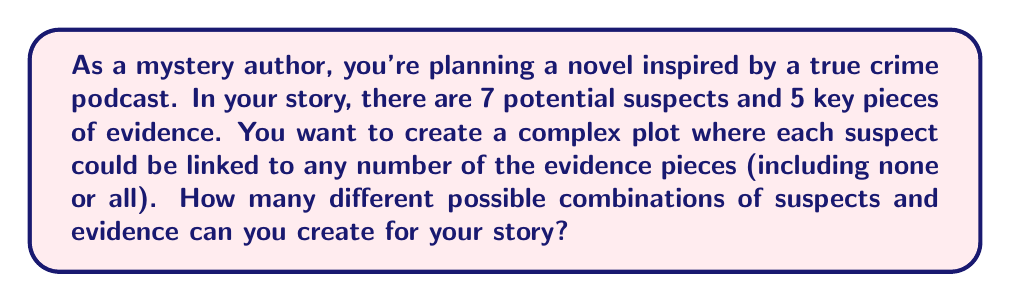Solve this math problem. Let's approach this step-by-step:

1) For each piece of evidence, we have two options for each suspect: they are either linked to it or not.

2) This means for each piece of evidence, we have 2 choices for each of the 7 suspects.

3) We can represent this mathematically as $2^7$ for each piece of evidence, because we're making 7 independent binary choices.

4) Since we have 5 pieces of evidence, and each piece of evidence can be independently assigned, we need to consider this choice 5 times.

5) Therefore, the total number of possible combinations is $(2^7)^5$.

6) We can simplify this:

   $$(2^7)^5 = 2^{7 \times 5} = 2^{35}$$

7) To calculate this:

   $$2^{35} = 34,359,738,368$$

This extremely large number represents all possible ways you could assign the evidence to the suspects in your story, allowing for complex and varied plot possibilities.
Answer: $2^{35} = 34,359,738,368$ possible combinations 